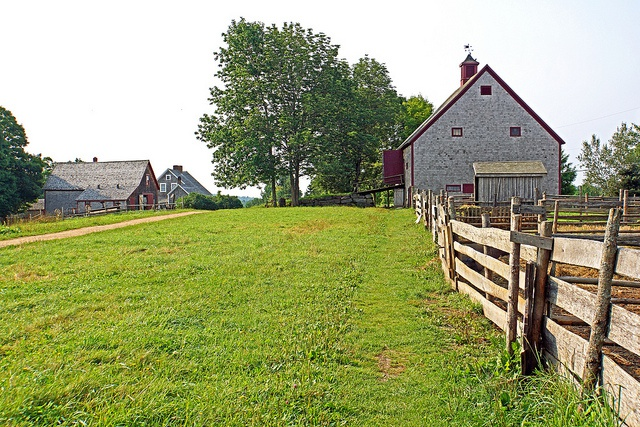Describe the objects in this image and their specific colors. I can see various objects in this image with different colors. 